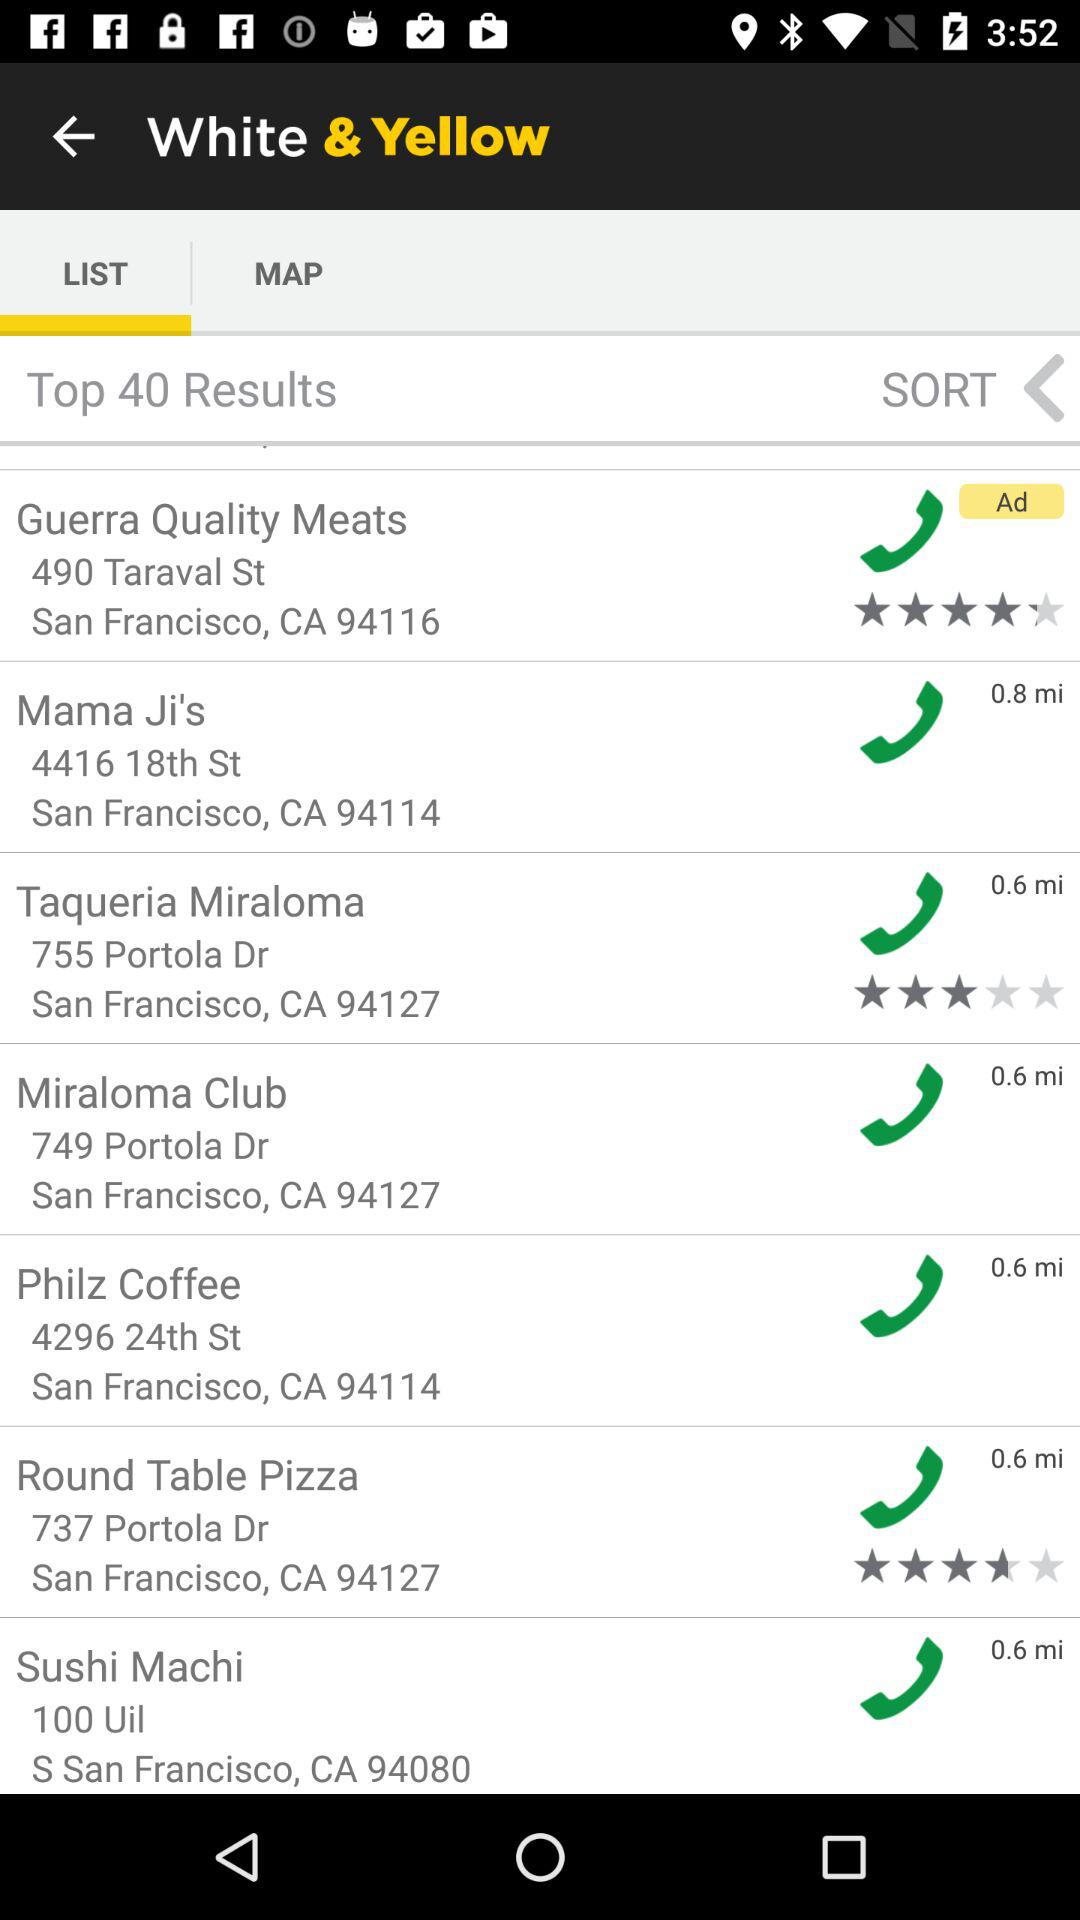What is the selected tab? The selected tab is "LIST". 